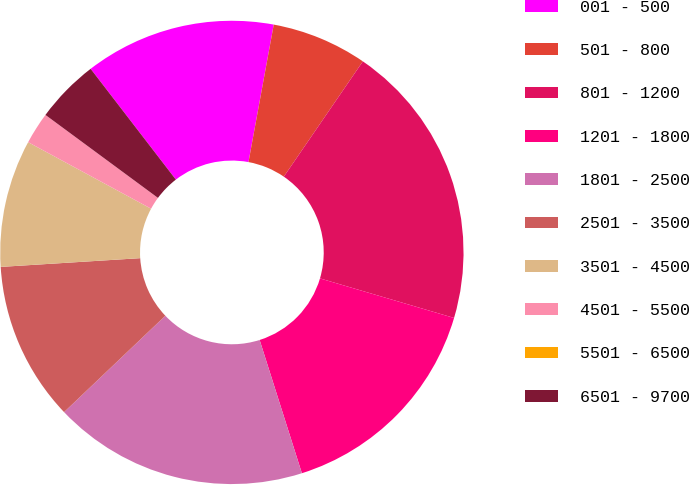<chart> <loc_0><loc_0><loc_500><loc_500><pie_chart><fcel>001 - 500<fcel>501 - 800<fcel>801 - 1200<fcel>1201 - 1800<fcel>1801 - 2500<fcel>2501 - 3500<fcel>3501 - 4500<fcel>4501 - 5500<fcel>5501 - 6500<fcel>6501 - 9700<nl><fcel>13.33%<fcel>6.67%<fcel>20.0%<fcel>15.55%<fcel>17.78%<fcel>11.11%<fcel>8.89%<fcel>2.22%<fcel>0.0%<fcel>4.45%<nl></chart> 